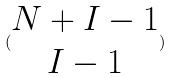<formula> <loc_0><loc_0><loc_500><loc_500>( \begin{matrix} N + I - 1 \\ I - 1 \end{matrix} )</formula> 